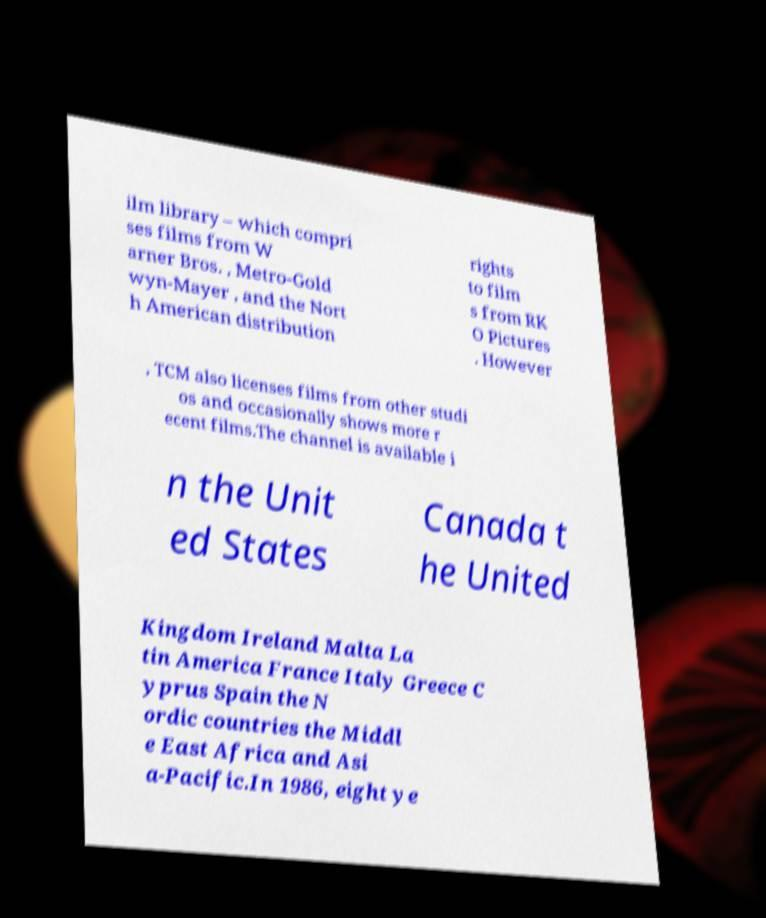Can you accurately transcribe the text from the provided image for me? ilm library – which compri ses films from W arner Bros. , Metro-Gold wyn-Mayer , and the Nort h American distribution rights to film s from RK O Pictures . However , TCM also licenses films from other studi os and occasionally shows more r ecent films.The channel is available i n the Unit ed States Canada t he United Kingdom Ireland Malta La tin America France Italy Greece C yprus Spain the N ordic countries the Middl e East Africa and Asi a-Pacific.In 1986, eight ye 